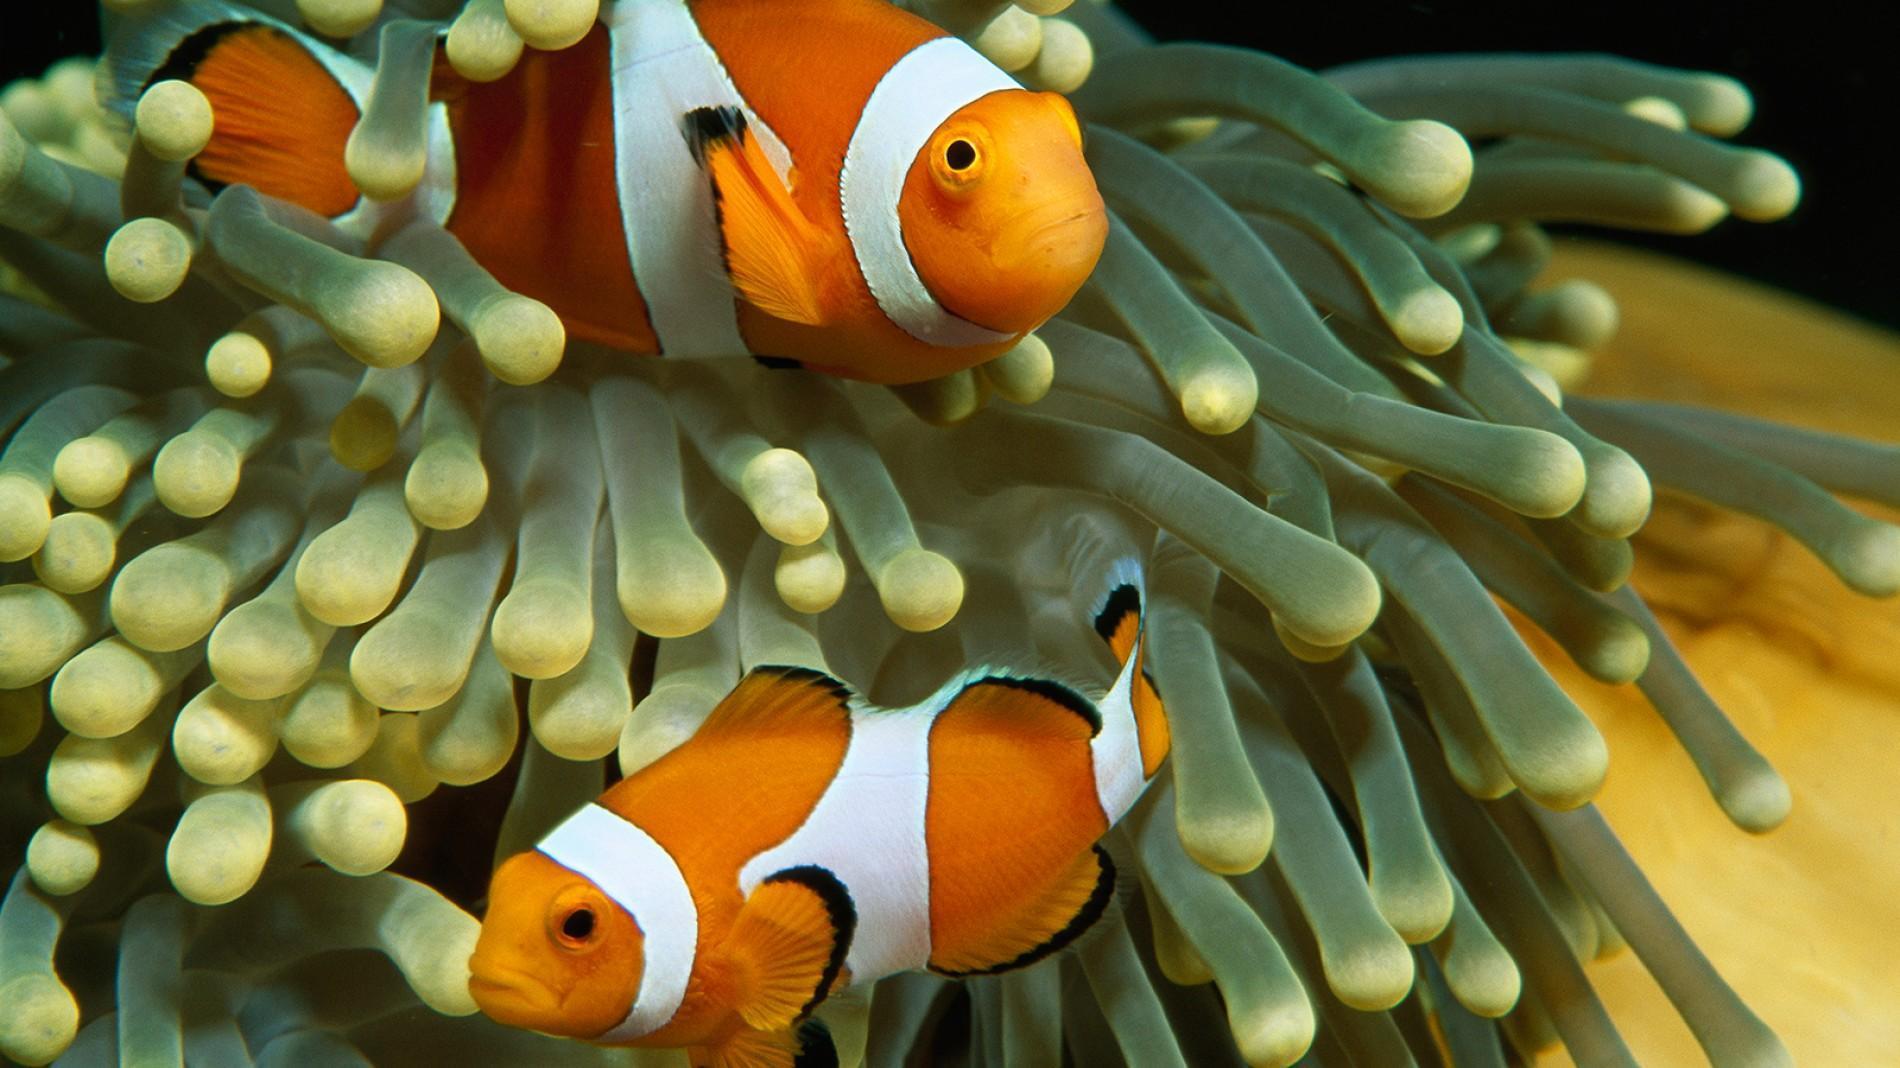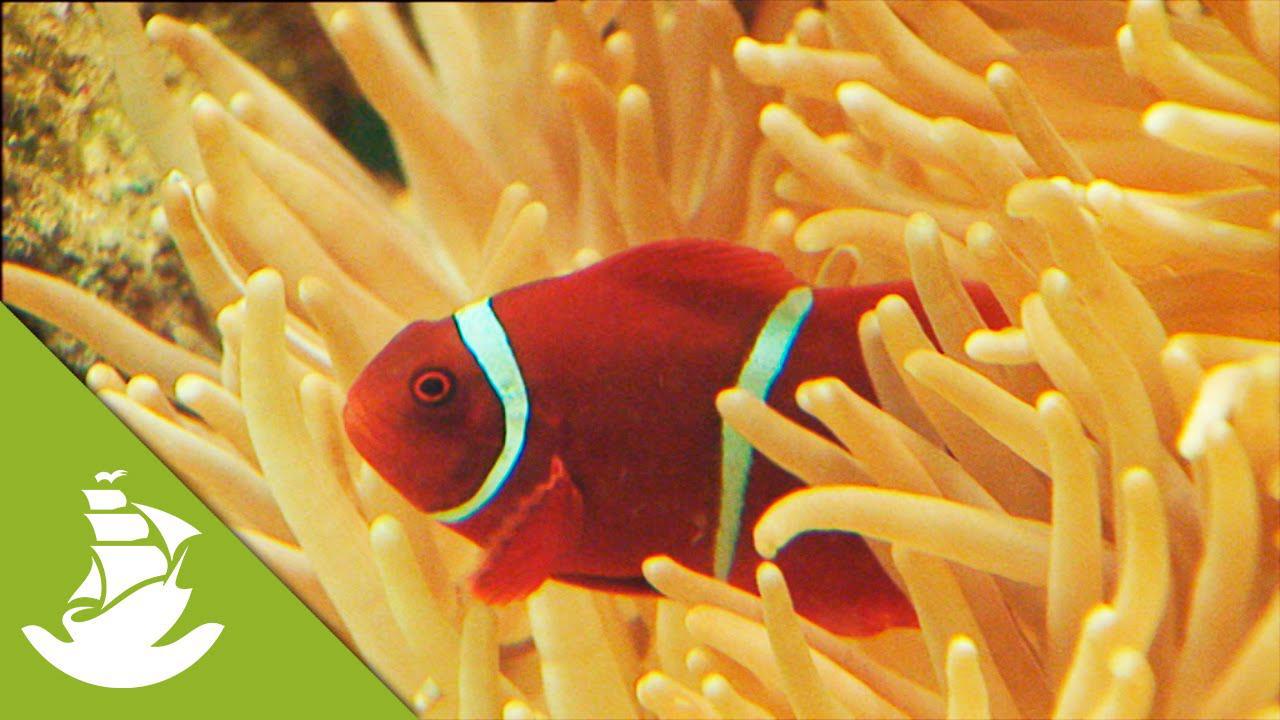The first image is the image on the left, the second image is the image on the right. Evaluate the accuracy of this statement regarding the images: "The left image features exactly two clown fish swimming in anemone tendrils, and the right image features one fish swimming in a different color of anemone tendrils.". Is it true? Answer yes or no. Yes. The first image is the image on the left, the second image is the image on the right. Analyze the images presented: Is the assertion "Exactly two clown-fish are interacting with an anemone in the left photo while exactly one fish is within the orange colored anemone in the right photo." valid? Answer yes or no. Yes. 